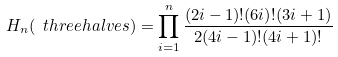<formula> <loc_0><loc_0><loc_500><loc_500>H _ { n } ( \ t h r e e h a l v e s ) = \prod _ { i = 1 } ^ { n } \frac { ( 2 i - 1 ) ! ( 6 i ) ! ( 3 i + 1 ) } { 2 ( 4 i - 1 ) ! ( 4 i + 1 ) ! }</formula> 